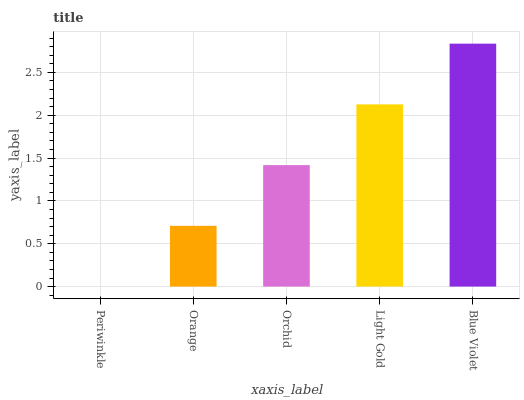Is Periwinkle the minimum?
Answer yes or no. Yes. Is Blue Violet the maximum?
Answer yes or no. Yes. Is Orange the minimum?
Answer yes or no. No. Is Orange the maximum?
Answer yes or no. No. Is Orange greater than Periwinkle?
Answer yes or no. Yes. Is Periwinkle less than Orange?
Answer yes or no. Yes. Is Periwinkle greater than Orange?
Answer yes or no. No. Is Orange less than Periwinkle?
Answer yes or no. No. Is Orchid the high median?
Answer yes or no. Yes. Is Orchid the low median?
Answer yes or no. Yes. Is Orange the high median?
Answer yes or no. No. Is Light Gold the low median?
Answer yes or no. No. 